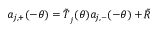<formula> <loc_0><loc_0><loc_500><loc_500>a _ { j , + } ( - \theta ) = \tilde { T } _ { _ { j } } ( \theta ) a _ { j , - } ( - \theta ) + \tilde { R }</formula> 